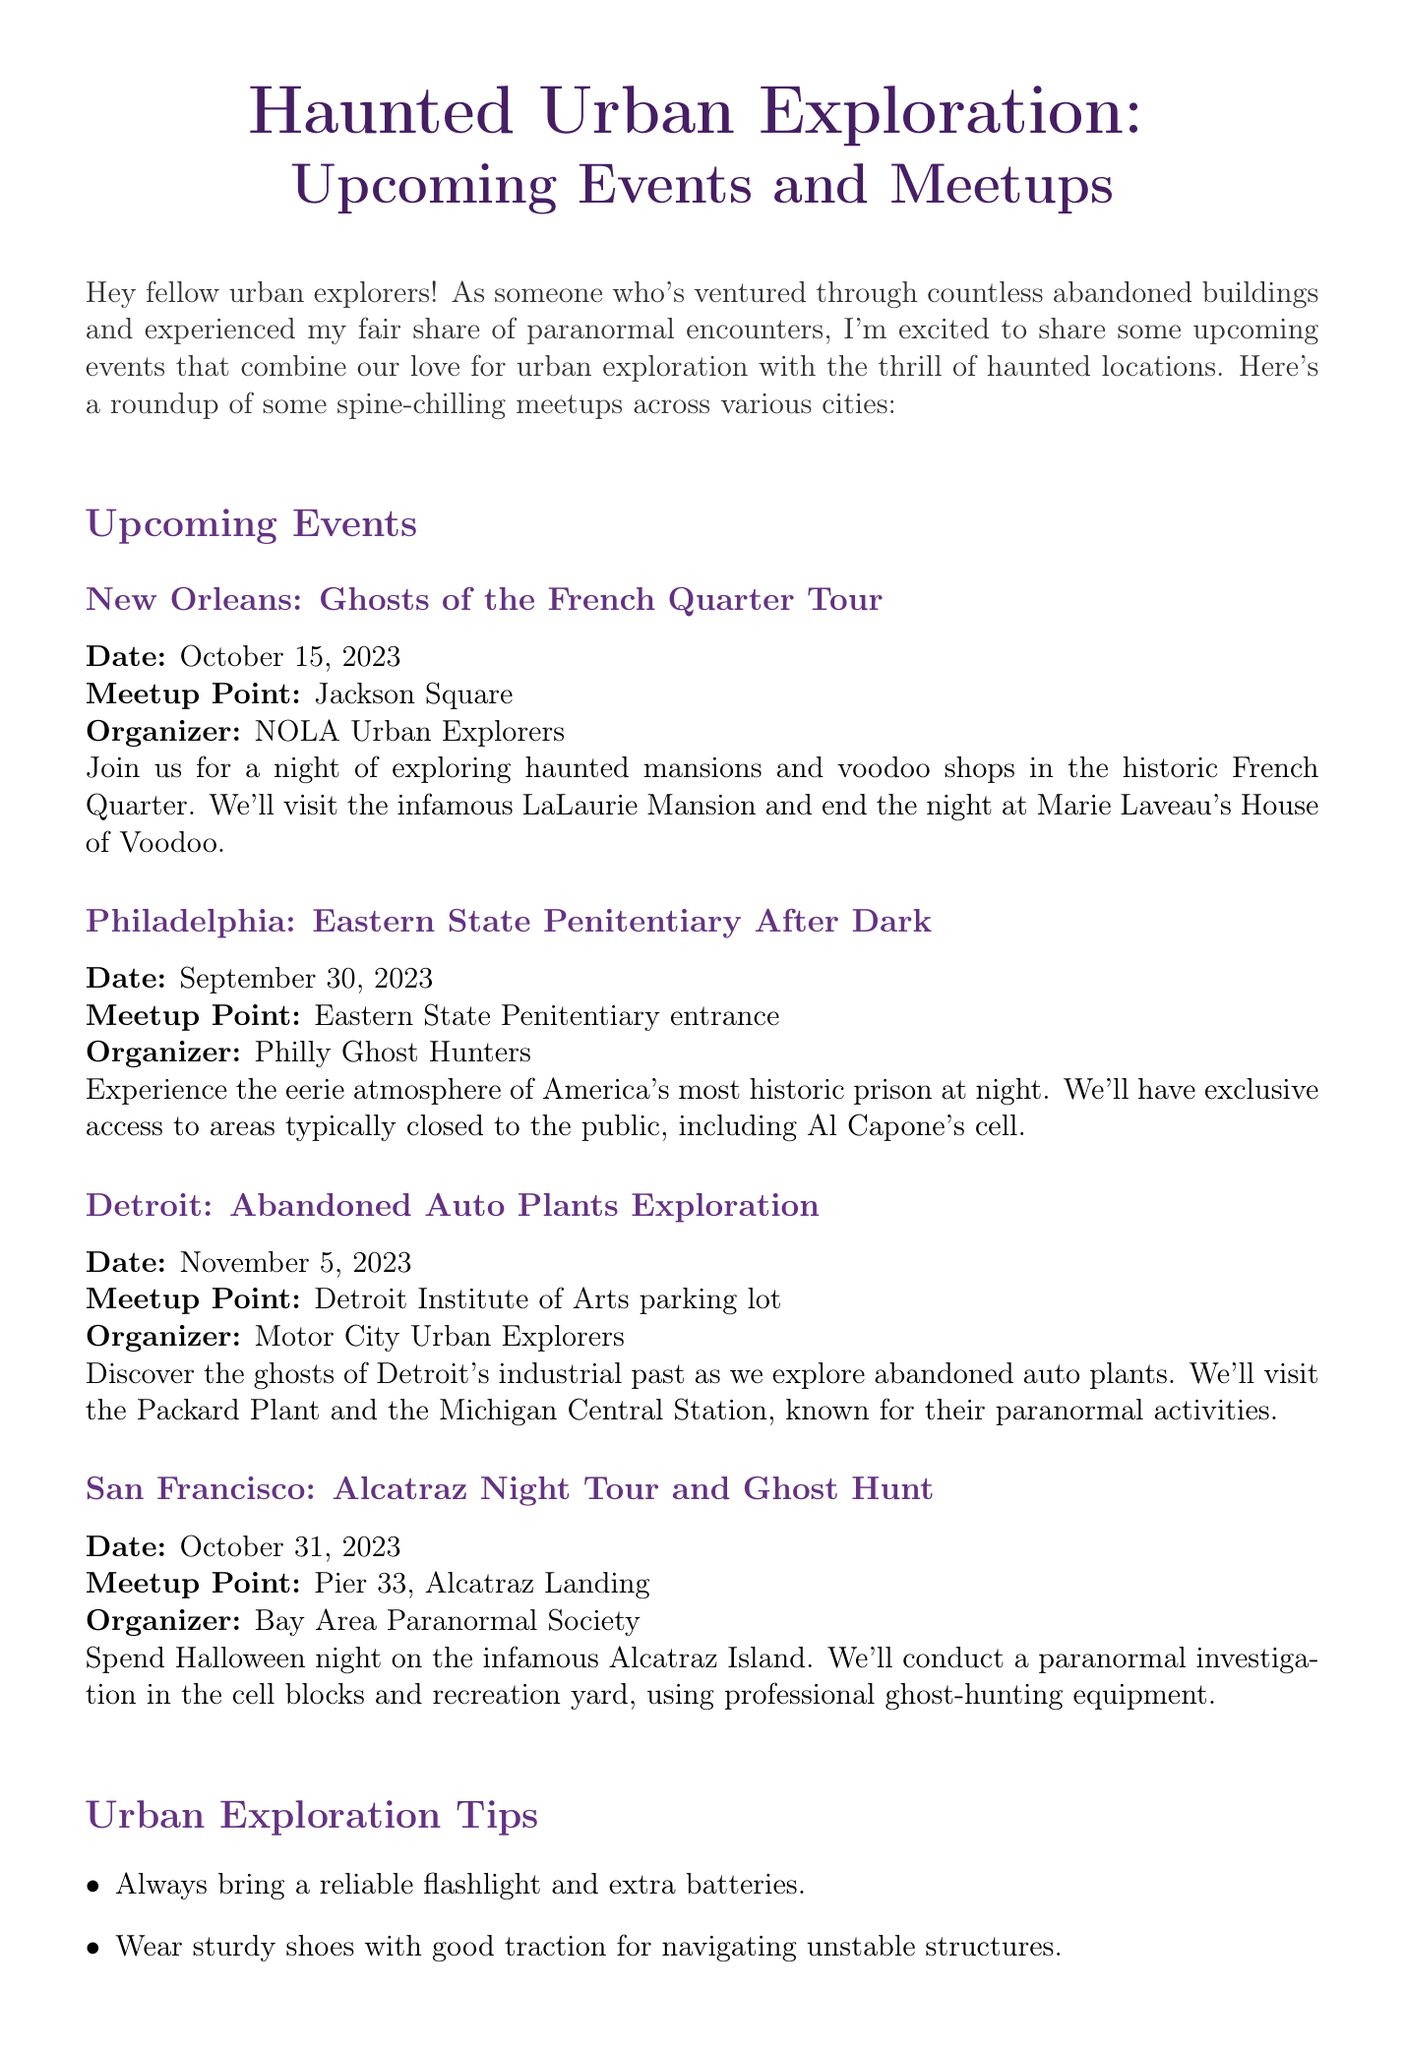what is the title of the newsletter? The title of the newsletter is provided at the beginning of the document.
Answer: Haunted Urban Exploration: Upcoming Events and Meetups where is the Ghosts of the French Quarter Tour located? The location of the event is mentioned in the event details for New Orleans.
Answer: New Orleans what is the date of the Eastern State Penitentiary After Dark event? The date is specified for the Eastern State Penitentiary event in the document.
Answer: September 30, 2023 who organizes the Alcatraz Night Tour and Ghost Hunt? The organizer's name is included in the event details for the San Francisco event.
Answer: Bay Area Paranormal Society how many urban exploration tips are provided? The number of tips can be counted from the tips section in the document.
Answer: Six which city will have an event on Halloween night? The city associated with the Halloween event is indicated in the San Francisco event details.
Answer: San Francisco what type of experience does the author share in the newsletter? The author's experience is described in the personal experience section of the document.
Answer: Paranormal encounters which two locations are included in the Detroit event description? The specific locations mentioned in the Detroit event need to be identified.
Answer: Packard Plant and Michigan Central Station 